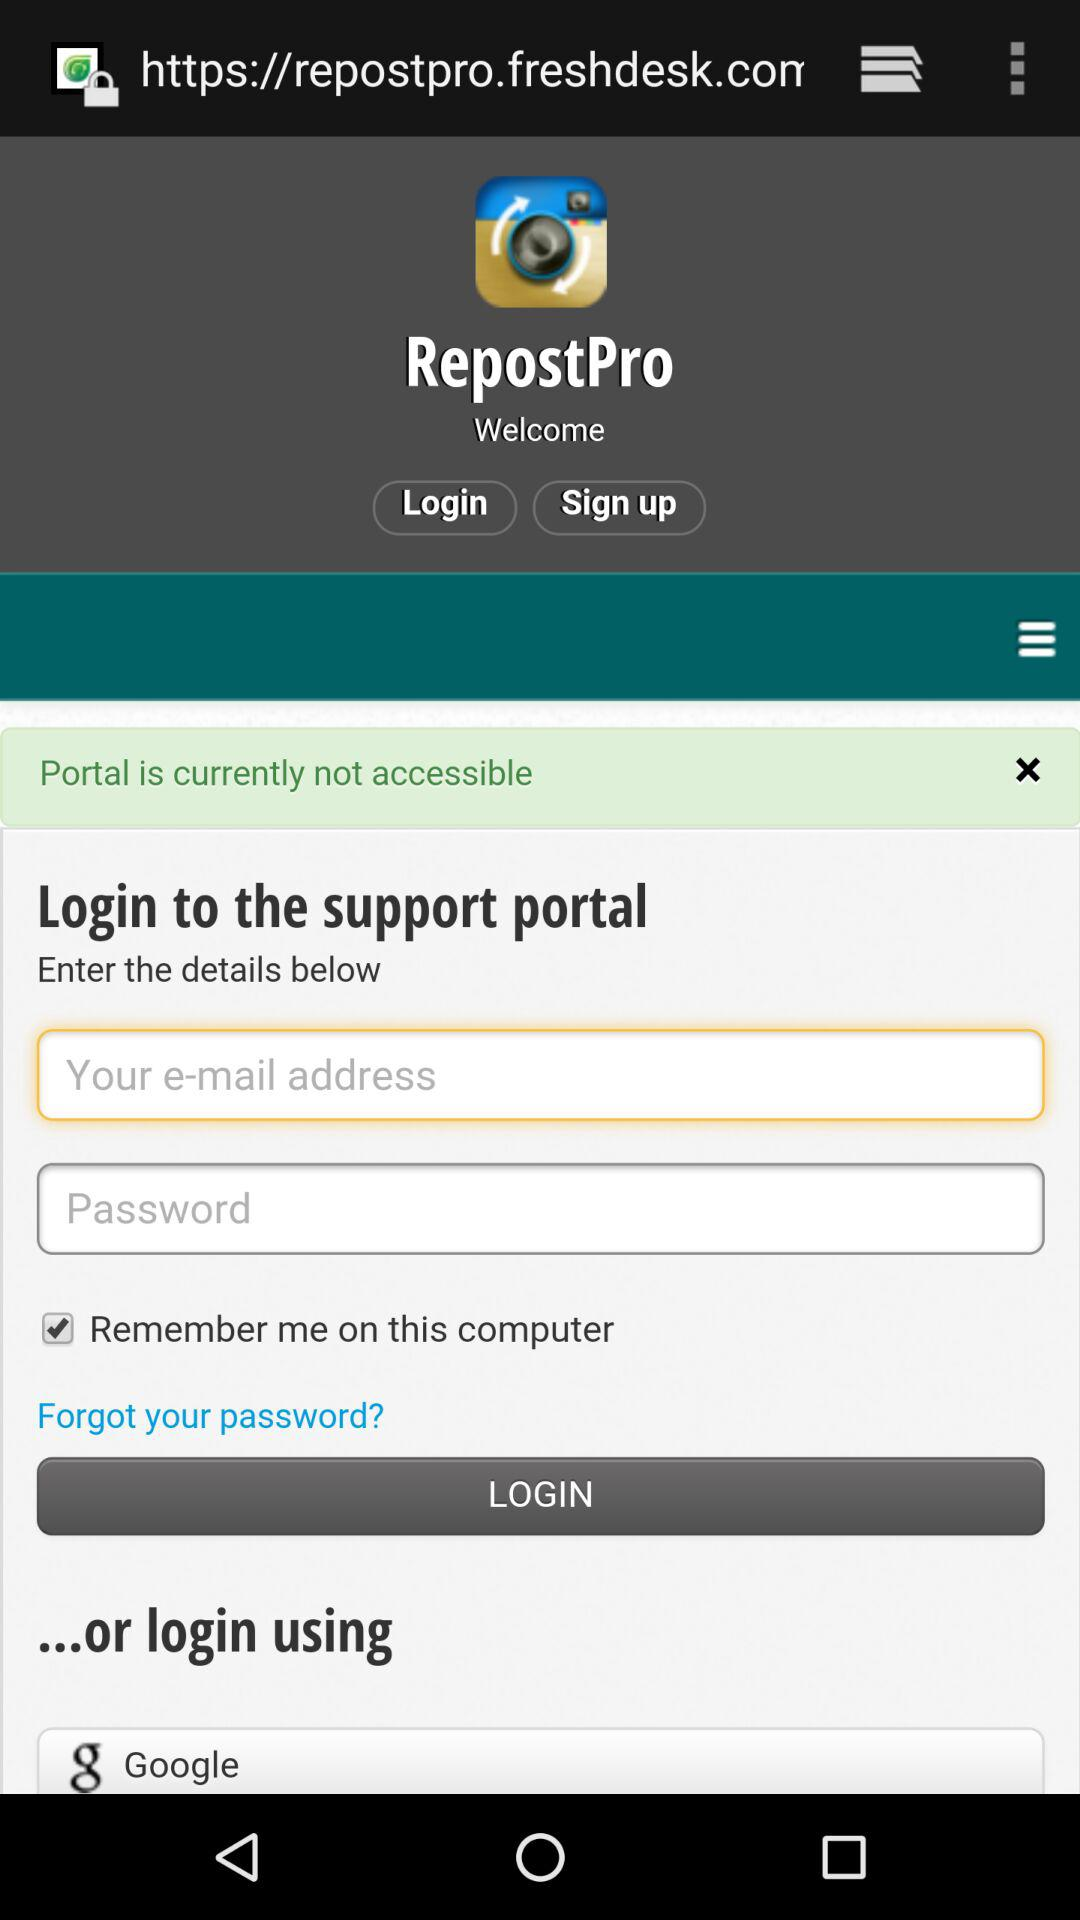What is the status of the portal? The portal is currently not accessible. 